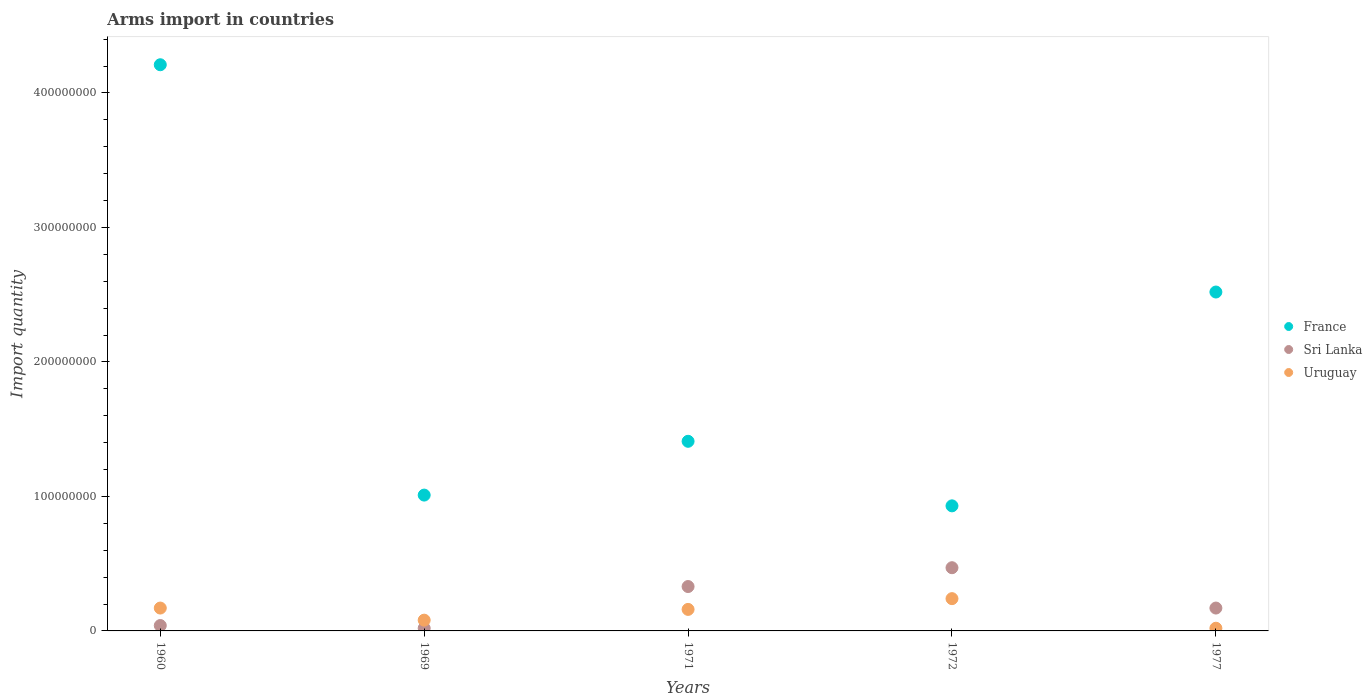Is the number of dotlines equal to the number of legend labels?
Provide a short and direct response. Yes. What is the total arms import in France in 1972?
Your response must be concise. 9.30e+07. Across all years, what is the maximum total arms import in Uruguay?
Offer a very short reply. 2.40e+07. What is the total total arms import in France in the graph?
Provide a short and direct response. 1.01e+09. What is the difference between the total arms import in Uruguay in 1972 and that in 1977?
Provide a succinct answer. 2.20e+07. What is the difference between the total arms import in France in 1969 and the total arms import in Uruguay in 1971?
Your answer should be compact. 8.50e+07. What is the average total arms import in France per year?
Provide a succinct answer. 2.02e+08. In the year 1977, what is the difference between the total arms import in Uruguay and total arms import in Sri Lanka?
Your answer should be very brief. -1.50e+07. In how many years, is the total arms import in Uruguay greater than 140000000?
Ensure brevity in your answer.  0. What is the ratio of the total arms import in Sri Lanka in 1971 to that in 1972?
Ensure brevity in your answer.  0.7. Is the total arms import in France in 1969 less than that in 1972?
Offer a very short reply. No. Is the difference between the total arms import in Uruguay in 1969 and 1971 greater than the difference between the total arms import in Sri Lanka in 1969 and 1971?
Keep it short and to the point. Yes. What is the difference between the highest and the lowest total arms import in France?
Offer a terse response. 3.28e+08. In how many years, is the total arms import in France greater than the average total arms import in France taken over all years?
Keep it short and to the point. 2. Is it the case that in every year, the sum of the total arms import in France and total arms import in Uruguay  is greater than the total arms import in Sri Lanka?
Your answer should be very brief. Yes. Is the total arms import in Sri Lanka strictly greater than the total arms import in France over the years?
Your answer should be compact. No. How many dotlines are there?
Provide a short and direct response. 3. How many years are there in the graph?
Keep it short and to the point. 5. What is the difference between two consecutive major ticks on the Y-axis?
Keep it short and to the point. 1.00e+08. Does the graph contain any zero values?
Provide a short and direct response. No. Does the graph contain grids?
Provide a short and direct response. No. Where does the legend appear in the graph?
Ensure brevity in your answer.  Center right. What is the title of the graph?
Give a very brief answer. Arms import in countries. Does "North America" appear as one of the legend labels in the graph?
Keep it short and to the point. No. What is the label or title of the Y-axis?
Ensure brevity in your answer.  Import quantity. What is the Import quantity in France in 1960?
Offer a very short reply. 4.21e+08. What is the Import quantity of Uruguay in 1960?
Make the answer very short. 1.70e+07. What is the Import quantity of France in 1969?
Make the answer very short. 1.01e+08. What is the Import quantity in Sri Lanka in 1969?
Make the answer very short. 2.00e+06. What is the Import quantity in Uruguay in 1969?
Give a very brief answer. 8.00e+06. What is the Import quantity in France in 1971?
Your answer should be very brief. 1.41e+08. What is the Import quantity of Sri Lanka in 1971?
Provide a succinct answer. 3.30e+07. What is the Import quantity in Uruguay in 1971?
Keep it short and to the point. 1.60e+07. What is the Import quantity in France in 1972?
Offer a very short reply. 9.30e+07. What is the Import quantity in Sri Lanka in 1972?
Offer a terse response. 4.70e+07. What is the Import quantity of Uruguay in 1972?
Your answer should be very brief. 2.40e+07. What is the Import quantity of France in 1977?
Ensure brevity in your answer.  2.52e+08. What is the Import quantity of Sri Lanka in 1977?
Keep it short and to the point. 1.70e+07. Across all years, what is the maximum Import quantity of France?
Make the answer very short. 4.21e+08. Across all years, what is the maximum Import quantity of Sri Lanka?
Your answer should be compact. 4.70e+07. Across all years, what is the maximum Import quantity in Uruguay?
Offer a very short reply. 2.40e+07. Across all years, what is the minimum Import quantity in France?
Ensure brevity in your answer.  9.30e+07. Across all years, what is the minimum Import quantity in Sri Lanka?
Your answer should be compact. 2.00e+06. Across all years, what is the minimum Import quantity of Uruguay?
Provide a short and direct response. 2.00e+06. What is the total Import quantity of France in the graph?
Give a very brief answer. 1.01e+09. What is the total Import quantity in Sri Lanka in the graph?
Your answer should be very brief. 1.03e+08. What is the total Import quantity in Uruguay in the graph?
Make the answer very short. 6.70e+07. What is the difference between the Import quantity in France in 1960 and that in 1969?
Give a very brief answer. 3.20e+08. What is the difference between the Import quantity of Sri Lanka in 1960 and that in 1969?
Your answer should be very brief. 2.00e+06. What is the difference between the Import quantity in Uruguay in 1960 and that in 1969?
Your answer should be compact. 9.00e+06. What is the difference between the Import quantity of France in 1960 and that in 1971?
Make the answer very short. 2.80e+08. What is the difference between the Import quantity in Sri Lanka in 1960 and that in 1971?
Provide a succinct answer. -2.90e+07. What is the difference between the Import quantity in Uruguay in 1960 and that in 1971?
Offer a terse response. 1.00e+06. What is the difference between the Import quantity of France in 1960 and that in 1972?
Offer a very short reply. 3.28e+08. What is the difference between the Import quantity in Sri Lanka in 1960 and that in 1972?
Offer a very short reply. -4.30e+07. What is the difference between the Import quantity in Uruguay in 1960 and that in 1972?
Offer a terse response. -7.00e+06. What is the difference between the Import quantity in France in 1960 and that in 1977?
Provide a succinct answer. 1.69e+08. What is the difference between the Import quantity in Sri Lanka in 1960 and that in 1977?
Make the answer very short. -1.30e+07. What is the difference between the Import quantity in Uruguay in 1960 and that in 1977?
Provide a short and direct response. 1.50e+07. What is the difference between the Import quantity in France in 1969 and that in 1971?
Keep it short and to the point. -4.00e+07. What is the difference between the Import quantity in Sri Lanka in 1969 and that in 1971?
Your answer should be very brief. -3.10e+07. What is the difference between the Import quantity of Uruguay in 1969 and that in 1971?
Ensure brevity in your answer.  -8.00e+06. What is the difference between the Import quantity in France in 1969 and that in 1972?
Your answer should be very brief. 8.00e+06. What is the difference between the Import quantity in Sri Lanka in 1969 and that in 1972?
Give a very brief answer. -4.50e+07. What is the difference between the Import quantity of Uruguay in 1969 and that in 1972?
Keep it short and to the point. -1.60e+07. What is the difference between the Import quantity of France in 1969 and that in 1977?
Give a very brief answer. -1.51e+08. What is the difference between the Import quantity of Sri Lanka in 1969 and that in 1977?
Offer a very short reply. -1.50e+07. What is the difference between the Import quantity in France in 1971 and that in 1972?
Your answer should be compact. 4.80e+07. What is the difference between the Import quantity in Sri Lanka in 1971 and that in 1972?
Give a very brief answer. -1.40e+07. What is the difference between the Import quantity of Uruguay in 1971 and that in 1972?
Make the answer very short. -8.00e+06. What is the difference between the Import quantity of France in 1971 and that in 1977?
Your answer should be very brief. -1.11e+08. What is the difference between the Import quantity in Sri Lanka in 1971 and that in 1977?
Your response must be concise. 1.60e+07. What is the difference between the Import quantity of Uruguay in 1971 and that in 1977?
Keep it short and to the point. 1.40e+07. What is the difference between the Import quantity in France in 1972 and that in 1977?
Make the answer very short. -1.59e+08. What is the difference between the Import quantity in Sri Lanka in 1972 and that in 1977?
Your answer should be compact. 3.00e+07. What is the difference between the Import quantity in Uruguay in 1972 and that in 1977?
Your response must be concise. 2.20e+07. What is the difference between the Import quantity in France in 1960 and the Import quantity in Sri Lanka in 1969?
Your answer should be very brief. 4.19e+08. What is the difference between the Import quantity of France in 1960 and the Import quantity of Uruguay in 1969?
Ensure brevity in your answer.  4.13e+08. What is the difference between the Import quantity of France in 1960 and the Import quantity of Sri Lanka in 1971?
Your answer should be compact. 3.88e+08. What is the difference between the Import quantity in France in 1960 and the Import quantity in Uruguay in 1971?
Your answer should be compact. 4.05e+08. What is the difference between the Import quantity in Sri Lanka in 1960 and the Import quantity in Uruguay in 1971?
Provide a succinct answer. -1.20e+07. What is the difference between the Import quantity of France in 1960 and the Import quantity of Sri Lanka in 1972?
Your answer should be very brief. 3.74e+08. What is the difference between the Import quantity of France in 1960 and the Import quantity of Uruguay in 1972?
Your answer should be very brief. 3.97e+08. What is the difference between the Import quantity of Sri Lanka in 1960 and the Import quantity of Uruguay in 1972?
Provide a succinct answer. -2.00e+07. What is the difference between the Import quantity in France in 1960 and the Import quantity in Sri Lanka in 1977?
Your response must be concise. 4.04e+08. What is the difference between the Import quantity in France in 1960 and the Import quantity in Uruguay in 1977?
Your response must be concise. 4.19e+08. What is the difference between the Import quantity in France in 1969 and the Import quantity in Sri Lanka in 1971?
Ensure brevity in your answer.  6.80e+07. What is the difference between the Import quantity in France in 1969 and the Import quantity in Uruguay in 1971?
Provide a short and direct response. 8.50e+07. What is the difference between the Import quantity of Sri Lanka in 1969 and the Import quantity of Uruguay in 1971?
Offer a terse response. -1.40e+07. What is the difference between the Import quantity of France in 1969 and the Import quantity of Sri Lanka in 1972?
Provide a succinct answer. 5.40e+07. What is the difference between the Import quantity of France in 1969 and the Import quantity of Uruguay in 1972?
Give a very brief answer. 7.70e+07. What is the difference between the Import quantity of Sri Lanka in 1969 and the Import quantity of Uruguay in 1972?
Keep it short and to the point. -2.20e+07. What is the difference between the Import quantity of France in 1969 and the Import quantity of Sri Lanka in 1977?
Keep it short and to the point. 8.40e+07. What is the difference between the Import quantity of France in 1969 and the Import quantity of Uruguay in 1977?
Make the answer very short. 9.90e+07. What is the difference between the Import quantity of France in 1971 and the Import quantity of Sri Lanka in 1972?
Ensure brevity in your answer.  9.40e+07. What is the difference between the Import quantity of France in 1971 and the Import quantity of Uruguay in 1972?
Ensure brevity in your answer.  1.17e+08. What is the difference between the Import quantity of Sri Lanka in 1971 and the Import quantity of Uruguay in 1972?
Offer a very short reply. 9.00e+06. What is the difference between the Import quantity in France in 1971 and the Import quantity in Sri Lanka in 1977?
Your answer should be compact. 1.24e+08. What is the difference between the Import quantity of France in 1971 and the Import quantity of Uruguay in 1977?
Ensure brevity in your answer.  1.39e+08. What is the difference between the Import quantity in Sri Lanka in 1971 and the Import quantity in Uruguay in 1977?
Ensure brevity in your answer.  3.10e+07. What is the difference between the Import quantity of France in 1972 and the Import quantity of Sri Lanka in 1977?
Your response must be concise. 7.60e+07. What is the difference between the Import quantity of France in 1972 and the Import quantity of Uruguay in 1977?
Your response must be concise. 9.10e+07. What is the difference between the Import quantity of Sri Lanka in 1972 and the Import quantity of Uruguay in 1977?
Give a very brief answer. 4.50e+07. What is the average Import quantity of France per year?
Keep it short and to the point. 2.02e+08. What is the average Import quantity in Sri Lanka per year?
Provide a short and direct response. 2.06e+07. What is the average Import quantity in Uruguay per year?
Provide a succinct answer. 1.34e+07. In the year 1960, what is the difference between the Import quantity in France and Import quantity in Sri Lanka?
Make the answer very short. 4.17e+08. In the year 1960, what is the difference between the Import quantity of France and Import quantity of Uruguay?
Offer a terse response. 4.04e+08. In the year 1960, what is the difference between the Import quantity of Sri Lanka and Import quantity of Uruguay?
Make the answer very short. -1.30e+07. In the year 1969, what is the difference between the Import quantity of France and Import quantity of Sri Lanka?
Provide a short and direct response. 9.90e+07. In the year 1969, what is the difference between the Import quantity of France and Import quantity of Uruguay?
Your answer should be compact. 9.30e+07. In the year 1969, what is the difference between the Import quantity of Sri Lanka and Import quantity of Uruguay?
Provide a short and direct response. -6.00e+06. In the year 1971, what is the difference between the Import quantity in France and Import quantity in Sri Lanka?
Give a very brief answer. 1.08e+08. In the year 1971, what is the difference between the Import quantity in France and Import quantity in Uruguay?
Provide a succinct answer. 1.25e+08. In the year 1971, what is the difference between the Import quantity in Sri Lanka and Import quantity in Uruguay?
Give a very brief answer. 1.70e+07. In the year 1972, what is the difference between the Import quantity in France and Import quantity in Sri Lanka?
Offer a terse response. 4.60e+07. In the year 1972, what is the difference between the Import quantity in France and Import quantity in Uruguay?
Provide a succinct answer. 6.90e+07. In the year 1972, what is the difference between the Import quantity in Sri Lanka and Import quantity in Uruguay?
Provide a short and direct response. 2.30e+07. In the year 1977, what is the difference between the Import quantity in France and Import quantity in Sri Lanka?
Make the answer very short. 2.35e+08. In the year 1977, what is the difference between the Import quantity of France and Import quantity of Uruguay?
Offer a very short reply. 2.50e+08. In the year 1977, what is the difference between the Import quantity in Sri Lanka and Import quantity in Uruguay?
Offer a very short reply. 1.50e+07. What is the ratio of the Import quantity of France in 1960 to that in 1969?
Make the answer very short. 4.17. What is the ratio of the Import quantity of Sri Lanka in 1960 to that in 1969?
Your answer should be very brief. 2. What is the ratio of the Import quantity in Uruguay in 1960 to that in 1969?
Your answer should be very brief. 2.12. What is the ratio of the Import quantity in France in 1960 to that in 1971?
Provide a succinct answer. 2.99. What is the ratio of the Import quantity of Sri Lanka in 1960 to that in 1971?
Your answer should be compact. 0.12. What is the ratio of the Import quantity in Uruguay in 1960 to that in 1971?
Offer a very short reply. 1.06. What is the ratio of the Import quantity in France in 1960 to that in 1972?
Give a very brief answer. 4.53. What is the ratio of the Import quantity of Sri Lanka in 1960 to that in 1972?
Offer a very short reply. 0.09. What is the ratio of the Import quantity of Uruguay in 1960 to that in 1972?
Give a very brief answer. 0.71. What is the ratio of the Import quantity in France in 1960 to that in 1977?
Your answer should be compact. 1.67. What is the ratio of the Import quantity in Sri Lanka in 1960 to that in 1977?
Ensure brevity in your answer.  0.24. What is the ratio of the Import quantity in Uruguay in 1960 to that in 1977?
Your response must be concise. 8.5. What is the ratio of the Import quantity of France in 1969 to that in 1971?
Provide a short and direct response. 0.72. What is the ratio of the Import quantity of Sri Lanka in 1969 to that in 1971?
Offer a very short reply. 0.06. What is the ratio of the Import quantity in France in 1969 to that in 1972?
Offer a very short reply. 1.09. What is the ratio of the Import quantity of Sri Lanka in 1969 to that in 1972?
Provide a short and direct response. 0.04. What is the ratio of the Import quantity of Uruguay in 1969 to that in 1972?
Keep it short and to the point. 0.33. What is the ratio of the Import quantity in France in 1969 to that in 1977?
Offer a very short reply. 0.4. What is the ratio of the Import quantity in Sri Lanka in 1969 to that in 1977?
Offer a very short reply. 0.12. What is the ratio of the Import quantity of Uruguay in 1969 to that in 1977?
Ensure brevity in your answer.  4. What is the ratio of the Import quantity of France in 1971 to that in 1972?
Your answer should be very brief. 1.52. What is the ratio of the Import quantity in Sri Lanka in 1971 to that in 1972?
Your answer should be very brief. 0.7. What is the ratio of the Import quantity in Uruguay in 1971 to that in 1972?
Your response must be concise. 0.67. What is the ratio of the Import quantity of France in 1971 to that in 1977?
Your response must be concise. 0.56. What is the ratio of the Import quantity in Sri Lanka in 1971 to that in 1977?
Your answer should be compact. 1.94. What is the ratio of the Import quantity in Uruguay in 1971 to that in 1977?
Provide a short and direct response. 8. What is the ratio of the Import quantity in France in 1972 to that in 1977?
Keep it short and to the point. 0.37. What is the ratio of the Import quantity in Sri Lanka in 1972 to that in 1977?
Provide a succinct answer. 2.76. What is the ratio of the Import quantity of Uruguay in 1972 to that in 1977?
Provide a short and direct response. 12. What is the difference between the highest and the second highest Import quantity of France?
Your response must be concise. 1.69e+08. What is the difference between the highest and the second highest Import quantity of Sri Lanka?
Your answer should be compact. 1.40e+07. What is the difference between the highest and the second highest Import quantity of Uruguay?
Make the answer very short. 7.00e+06. What is the difference between the highest and the lowest Import quantity in France?
Your answer should be very brief. 3.28e+08. What is the difference between the highest and the lowest Import quantity of Sri Lanka?
Offer a very short reply. 4.50e+07. What is the difference between the highest and the lowest Import quantity of Uruguay?
Give a very brief answer. 2.20e+07. 